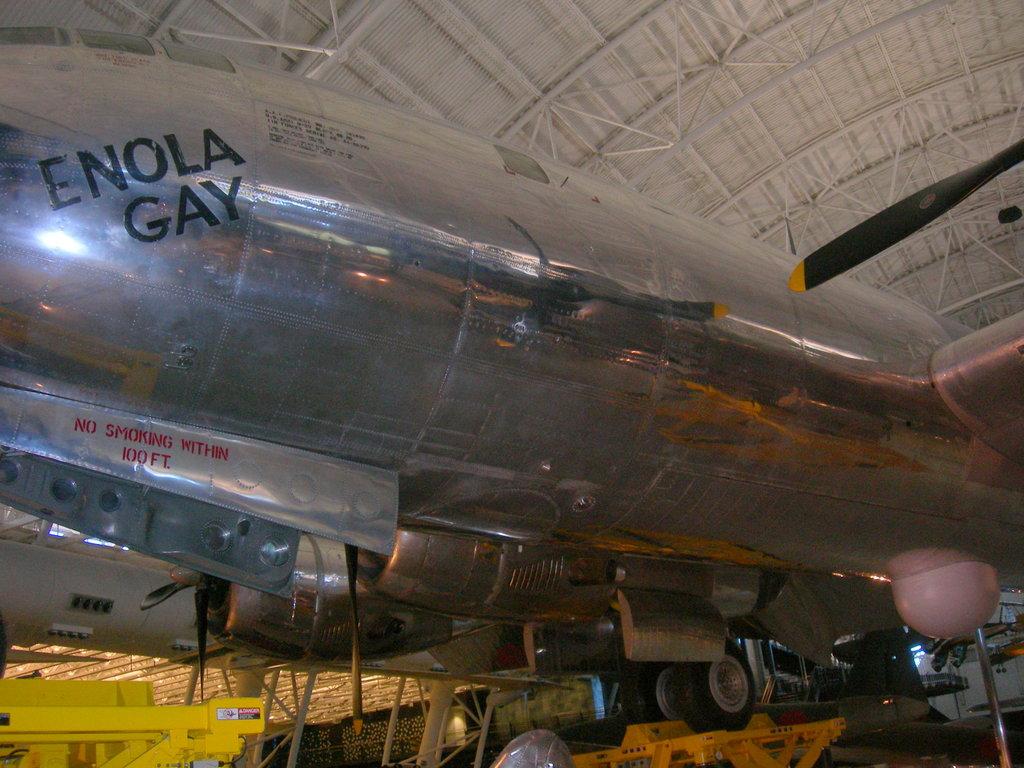What is the name of this airplane?
Offer a very short reply. Enola gay. 